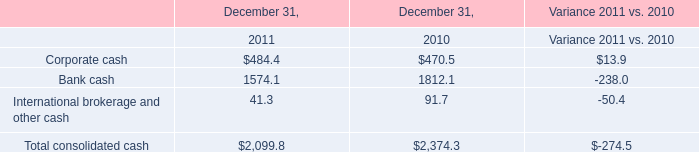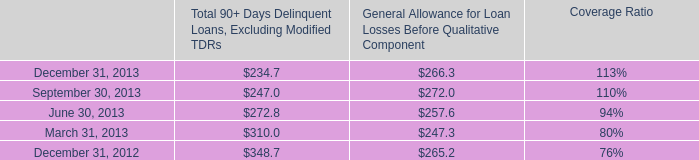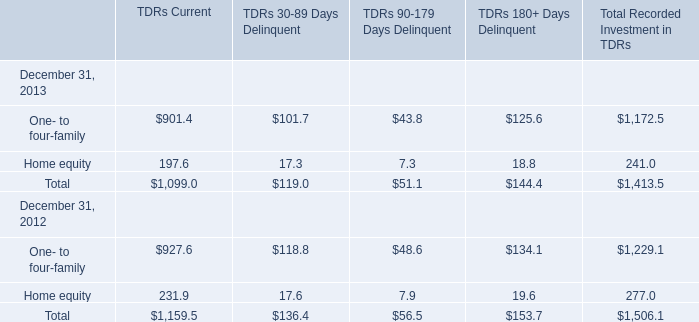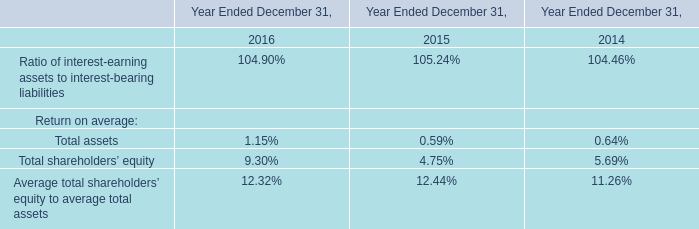What was the average of Total 90+ Days Delinquent Loans, Excluding Modified TDRs for September 30, 2013, June 30, 2013, and March 31, 2013 ? 
Computations: (((247.0 + 272.8) + 310.0) / 3)
Answer: 276.6. 